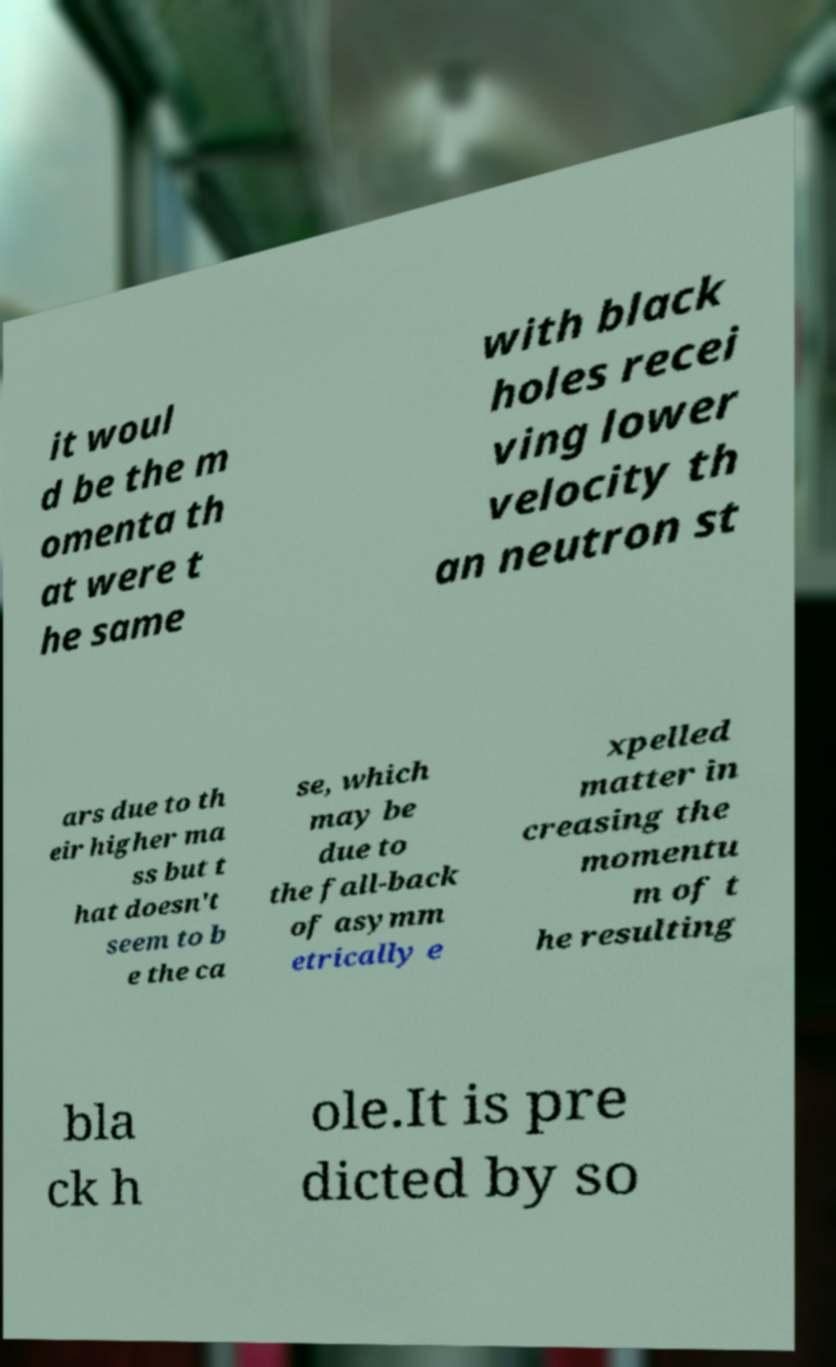For documentation purposes, I need the text within this image transcribed. Could you provide that? it woul d be the m omenta th at were t he same with black holes recei ving lower velocity th an neutron st ars due to th eir higher ma ss but t hat doesn't seem to b e the ca se, which may be due to the fall-back of asymm etrically e xpelled matter in creasing the momentu m of t he resulting bla ck h ole.It is pre dicted by so 